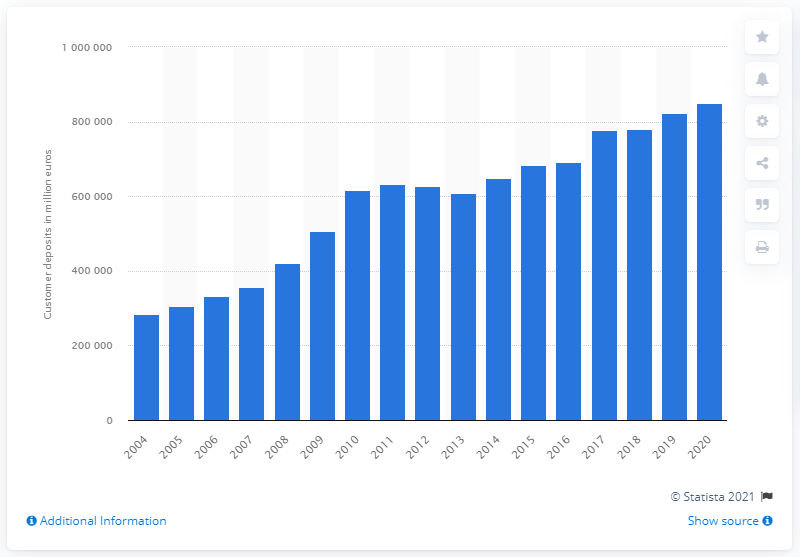Specify some key components in this picture. In 2004, the value of customer deposits at Santander was 283,212. In 2004, the highest value of customer deposits was recorded in Santander. 